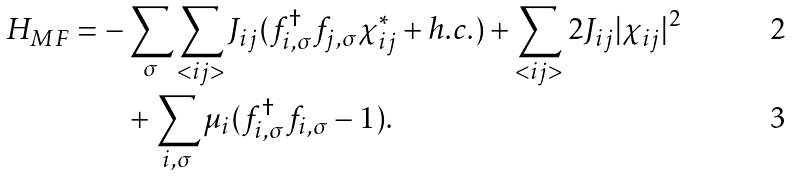<formula> <loc_0><loc_0><loc_500><loc_500>H _ { M F } = - & \sum _ { \sigma } \sum _ { < i j > } J _ { i j } ( f ^ { \dag } _ { i , \sigma } f _ { j , \sigma } \chi ^ { * } _ { i j } + h . c . ) + \sum _ { < i j > } 2 J _ { i j } | \chi _ { i j } | ^ { 2 } \\ \quad & + \sum _ { i , \sigma } \mu _ { i } ( f ^ { \dag } _ { i , \sigma } f _ { i , \sigma } - 1 ) .</formula> 